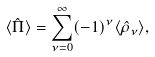<formula> <loc_0><loc_0><loc_500><loc_500>\langle \hat { \Pi } \rangle = \sum _ { \nu = 0 } ^ { \infty } ( - 1 ) ^ { \nu } \langle \hat { \rho } _ { \nu } \rangle ,</formula> 